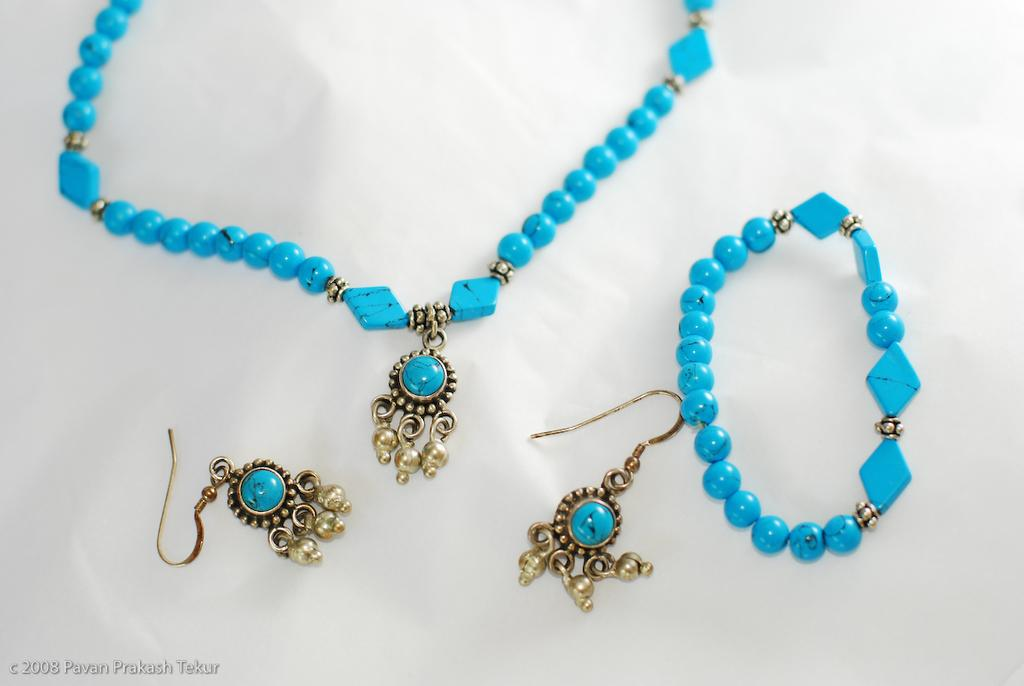What type of jewelry is visible in the image? There is a necklace, earrings, and a bracelet in the image. What color are the jewelry items in the image? The necklace, earrings, and bracelet are all blue. On what surface are the jewelry items placed? The items are placed on a white surface. Is there any additional mark or feature in the image? Yes, there is a watermark present in the bottom left side of the image. What type of yard is visible in the image? There is no yard visible in the image; it features jewelry items placed on a white surface. How are the oatmeal items sorted in the image? There are no oatmeal items present in the image. 